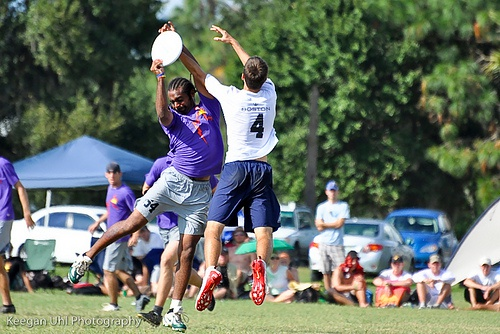Describe the objects in this image and their specific colors. I can see people in black, white, blue, and darkgray tones, people in black, navy, white, and gray tones, car in black, white, gray, and darkgray tones, people in black, gray, lightgray, violet, and darkgray tones, and car in black, white, darkgray, and gray tones in this image. 